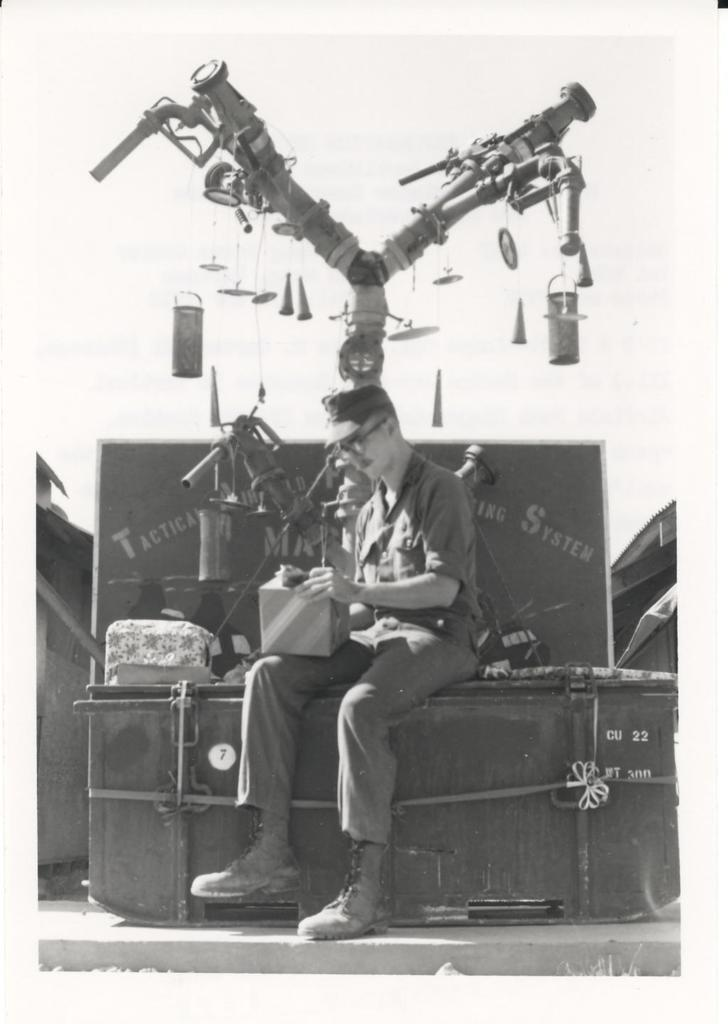What is the person in the image doing? The person is sitting in the image. What is the person holding in the image? The person is holding something. What can be seen in the background of the image? There are objects visible in the background. What is the color scheme of the image? The image is in black and white. How many dogs are visible in the image? There are no dogs present in the image. Is the person wearing a scarf in the image? The provided facts do not mention a scarf, so we cannot determine if the person is wearing one. How many friends are sitting with the person in the image? The provided facts do not mention any friends, so we cannot determine if there are any friends sitting with the person. 